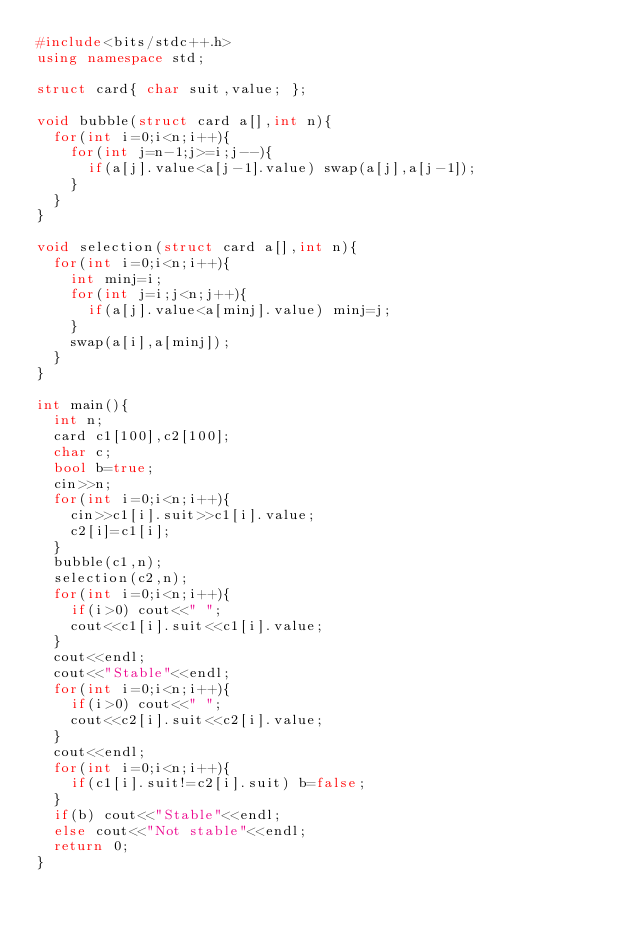<code> <loc_0><loc_0><loc_500><loc_500><_C++_>#include<bits/stdc++.h>
using namespace std;

struct card{ char suit,value; };
  
void bubble(struct card a[],int n){
  for(int i=0;i<n;i++){
    for(int j=n-1;j>=i;j--){
      if(a[j].value<a[j-1].value) swap(a[j],a[j-1]);
    }
  }
}

void selection(struct card a[],int n){
  for(int i=0;i<n;i++){
    int minj=i;
    for(int j=i;j<n;j++){
      if(a[j].value<a[minj].value) minj=j;
    }
    swap(a[i],a[minj]);
  }
}

int main(){
  int n;
  card c1[100],c2[100];
  char c;
  bool b=true;
  cin>>n;
  for(int i=0;i<n;i++){
    cin>>c1[i].suit>>c1[i].value;
    c2[i]=c1[i];
  }
  bubble(c1,n);
  selection(c2,n);
  for(int i=0;i<n;i++){
    if(i>0) cout<<" ";
    cout<<c1[i].suit<<c1[i].value;
  }
  cout<<endl;
  cout<<"Stable"<<endl;
  for(int i=0;i<n;i++){
    if(i>0) cout<<" ";
    cout<<c2[i].suit<<c2[i].value;
  }
  cout<<endl;
  for(int i=0;i<n;i++){
    if(c1[i].suit!=c2[i].suit) b=false;
  }
  if(b) cout<<"Stable"<<endl;
  else cout<<"Not stable"<<endl;
  return 0;
}

</code> 